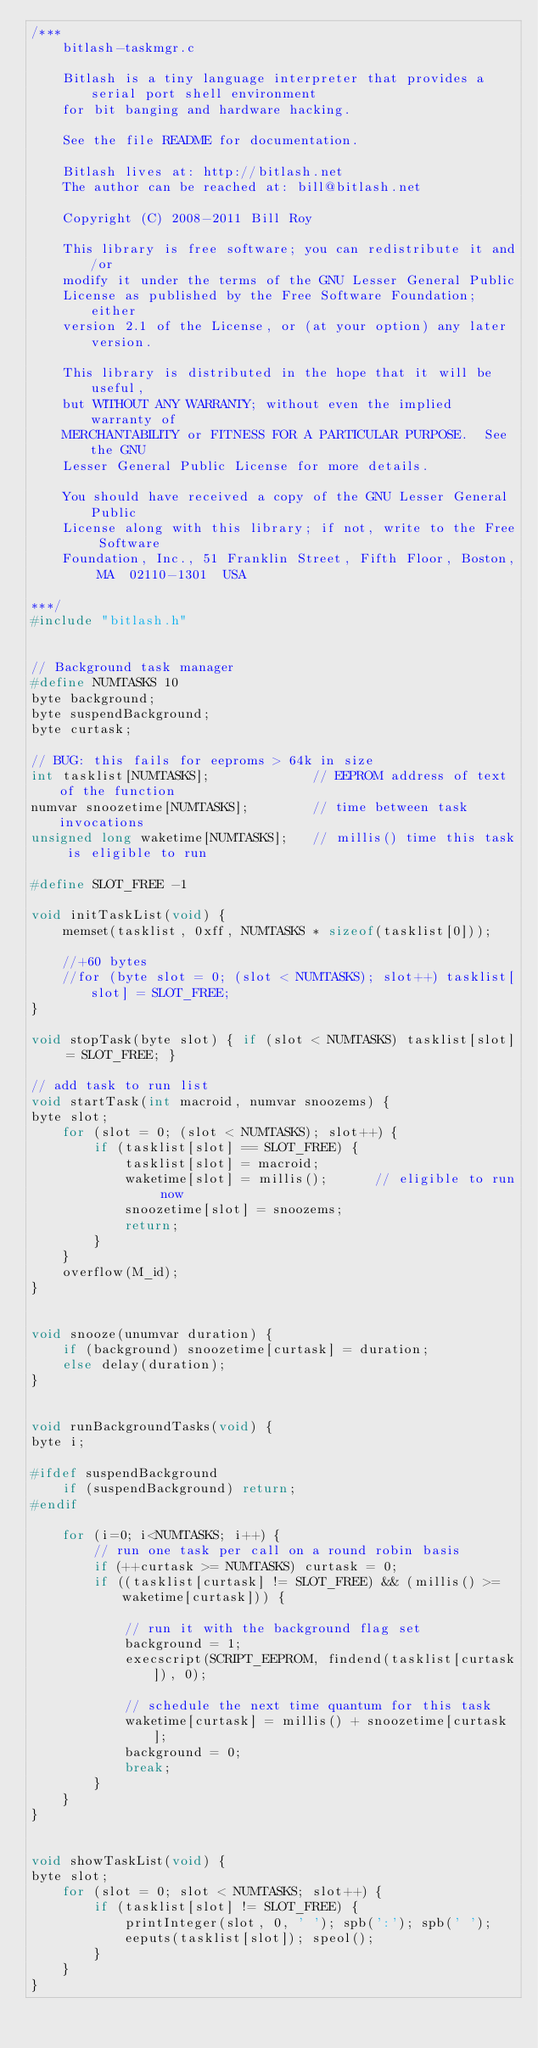Convert code to text. <code><loc_0><loc_0><loc_500><loc_500><_C_>/***
	bitlash-taskmgr.c

	Bitlash is a tiny language interpreter that provides a serial port shell environment
	for bit banging and hardware hacking.

	See the file README for documentation.

	Bitlash lives at: http://bitlash.net
	The author can be reached at: bill@bitlash.net

	Copyright (C) 2008-2011 Bill Roy

    This library is free software; you can redistribute it and/or
    modify it under the terms of the GNU Lesser General Public
    License as published by the Free Software Foundation; either
    version 2.1 of the License, or (at your option) any later version.

    This library is distributed in the hope that it will be useful,
    but WITHOUT ANY WARRANTY; without even the implied warranty of
    MERCHANTABILITY or FITNESS FOR A PARTICULAR PURPOSE.  See the GNU
    Lesser General Public License for more details.

    You should have received a copy of the GNU Lesser General Public
    License along with this library; if not, write to the Free Software
    Foundation, Inc., 51 Franklin Street, Fifth Floor, Boston, MA  02110-1301  USA

***/
#include "bitlash.h"


// Background task manager
#define NUMTASKS 10
byte background;
byte suspendBackground;
byte curtask;

// BUG: this fails for eeproms > 64k in size
int tasklist[NUMTASKS];				// EEPROM address of text of the function
numvar snoozetime[NUMTASKS];		// time between task invocations
unsigned long waketime[NUMTASKS];	// millis() time this task is eligible to run

#define SLOT_FREE -1

void initTaskList(void) { 
	memset(tasklist, 0xff, NUMTASKS * sizeof(tasklist[0]));

	//+60 bytes
	//for (byte slot = 0; (slot < NUMTASKS); slot++) tasklist[slot] = SLOT_FREE;
}

void stopTask(byte slot) { if (slot < NUMTASKS) tasklist[slot] = SLOT_FREE; }

// add task to run list
void startTask(int macroid, numvar snoozems) {
byte slot;
	for (slot = 0; (slot < NUMTASKS); slot++) {
		if (tasklist[slot] == SLOT_FREE) {
			tasklist[slot] = macroid;
			waketime[slot] = millis();		// eligible to run now
			snoozetime[slot] = snoozems;
			return;
		}
	}
	overflow(M_id);
}


void snooze(unumvar duration) {
	if (background) snoozetime[curtask] = duration;
	else delay(duration);
}


void runBackgroundTasks(void) {
byte i;	

#ifdef suspendBackground
	if (suspendBackground) return;
#endif

	for (i=0; i<NUMTASKS; i++) {
		// run one task per call on a round robin basis
		if (++curtask >= NUMTASKS) curtask = 0;
		if ((tasklist[curtask] != SLOT_FREE) && (millis() >= waketime[curtask])) {

			// run it with the background flag set
			background = 1;
			execscript(SCRIPT_EEPROM, findend(tasklist[curtask]), 0);

			// schedule the next time quantum for this task
			waketime[curtask] = millis() + snoozetime[curtask];
			background = 0;
			break;
		}
	}
}


void showTaskList(void) {
byte slot;
	for (slot = 0; slot < NUMTASKS; slot++) {
		if (tasklist[slot] != SLOT_FREE) {
			printInteger(slot, 0, ' '); spb(':'); spb(' ');
			eeputs(tasklist[slot]); speol();
		}
	}
}


</code> 